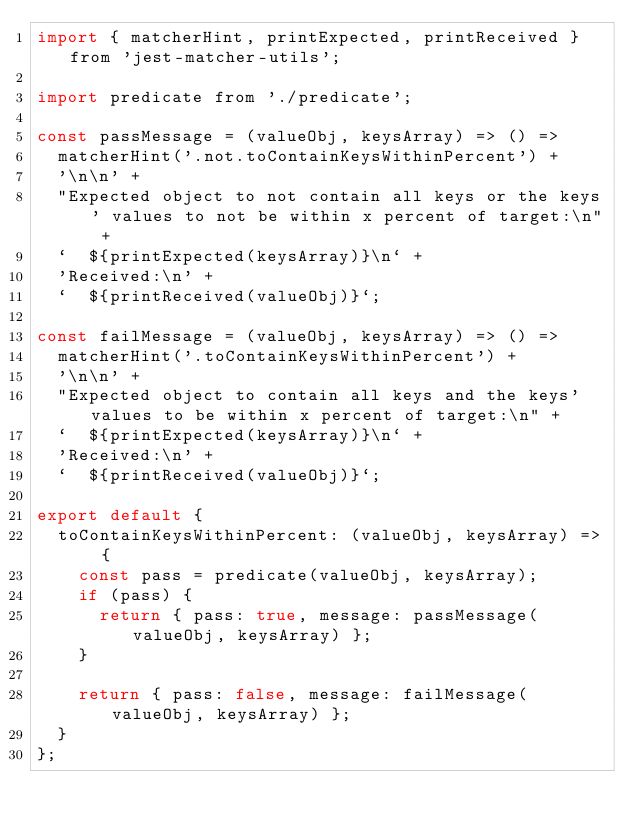<code> <loc_0><loc_0><loc_500><loc_500><_JavaScript_>import { matcherHint, printExpected, printReceived } from 'jest-matcher-utils';

import predicate from './predicate';

const passMessage = (valueObj, keysArray) => () =>
  matcherHint('.not.toContainKeysWithinPercent') +
  '\n\n' +
  "Expected object to not contain all keys or the keys' values to not be within x percent of target:\n" +
  `  ${printExpected(keysArray)}\n` +
  'Received:\n' +
  `  ${printReceived(valueObj)}`;

const failMessage = (valueObj, keysArray) => () =>
  matcherHint('.toContainKeysWithinPercent') +
  '\n\n' +
  "Expected object to contain all keys and the keys' values to be within x percent of target:\n" +
  `  ${printExpected(keysArray)}\n` +
  'Received:\n' +
  `  ${printReceived(valueObj)}`;

export default {
  toContainKeysWithinPercent: (valueObj, keysArray) => {
    const pass = predicate(valueObj, keysArray);
    if (pass) {
      return { pass: true, message: passMessage(valueObj, keysArray) };
    }

    return { pass: false, message: failMessage(valueObj, keysArray) };
  }
};
</code> 